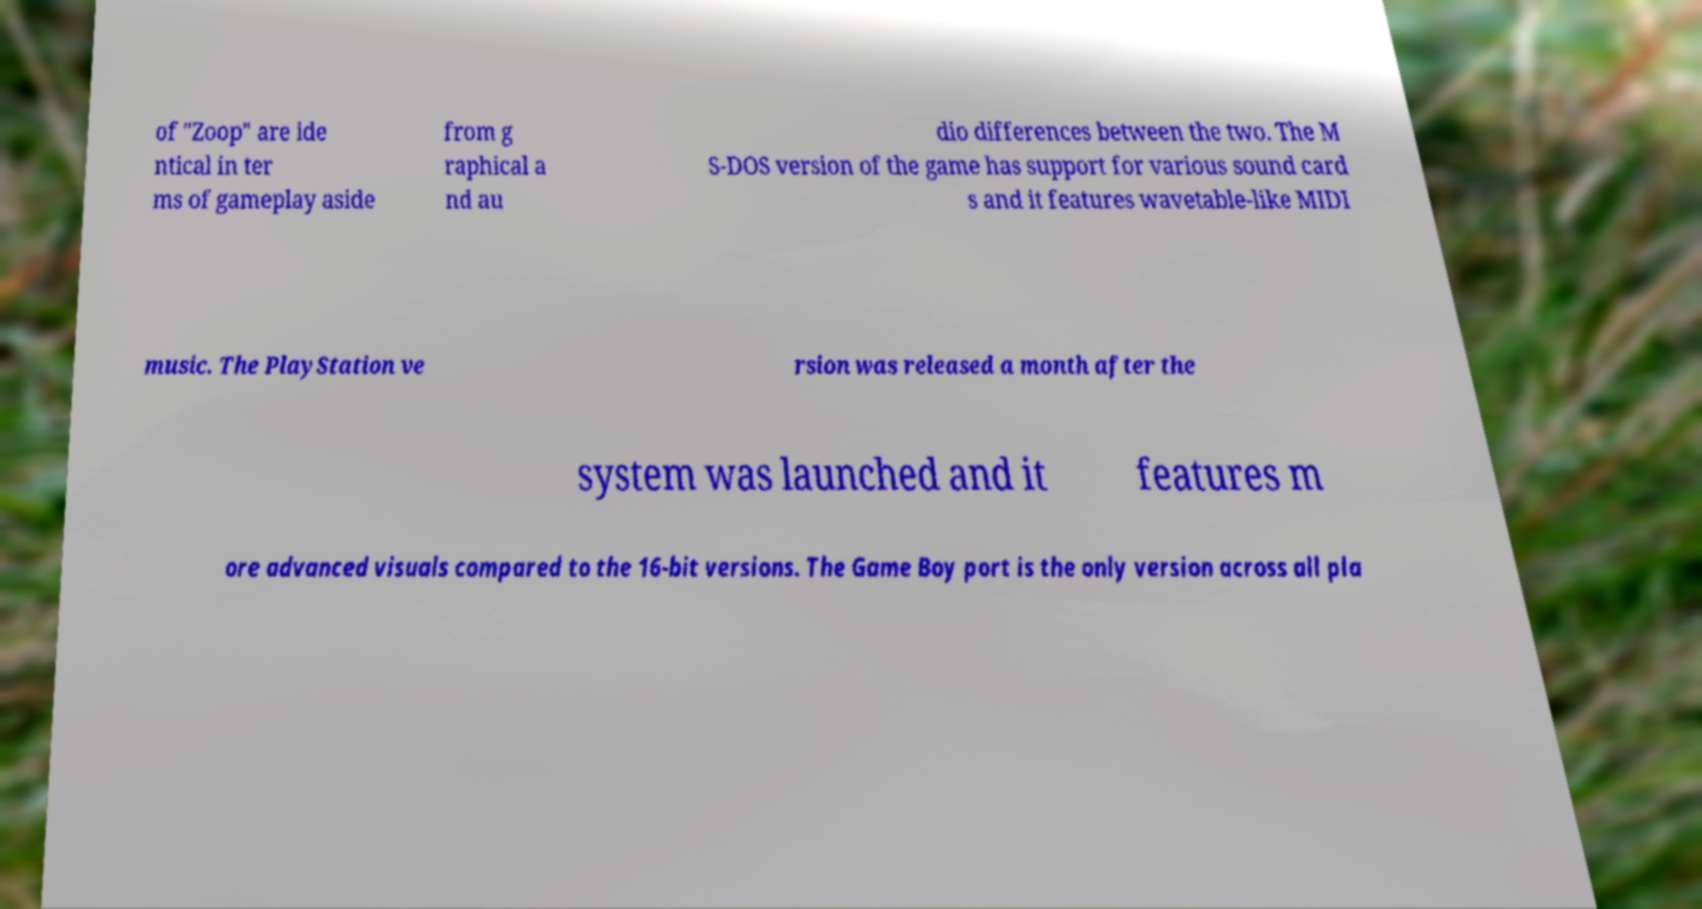I need the written content from this picture converted into text. Can you do that? of "Zoop" are ide ntical in ter ms of gameplay aside from g raphical a nd au dio differences between the two. The M S-DOS version of the game has support for various sound card s and it features wavetable-like MIDI music. The PlayStation ve rsion was released a month after the system was launched and it features m ore advanced visuals compared to the 16-bit versions. The Game Boy port is the only version across all pla 